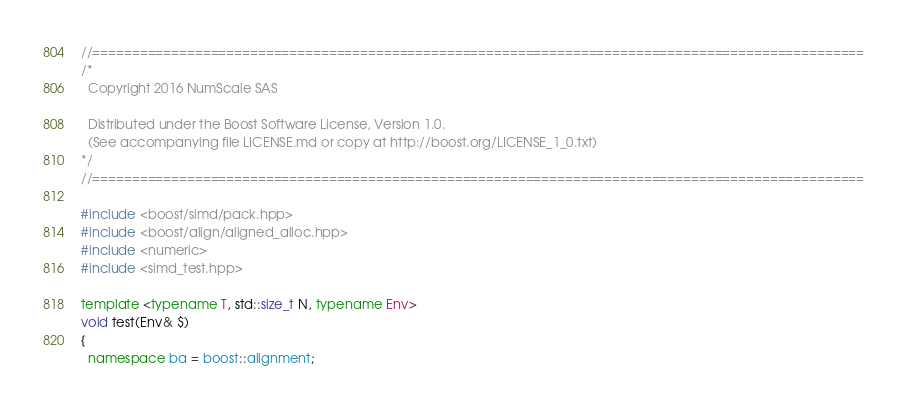Convert code to text. <code><loc_0><loc_0><loc_500><loc_500><_C++_>//==================================================================================================
/*
  Copyright 2016 NumScale SAS

  Distributed under the Boost Software License, Version 1.0.
  (See accompanying file LICENSE.md or copy at http://boost.org/LICENSE_1_0.txt)
*/
//==================================================================================================

#include <boost/simd/pack.hpp>
#include <boost/align/aligned_alloc.hpp>
#include <numeric>
#include <simd_test.hpp>

template <typename T, std::size_t N, typename Env>
void test(Env& $)
{
  namespace ba = boost::alignment;</code> 